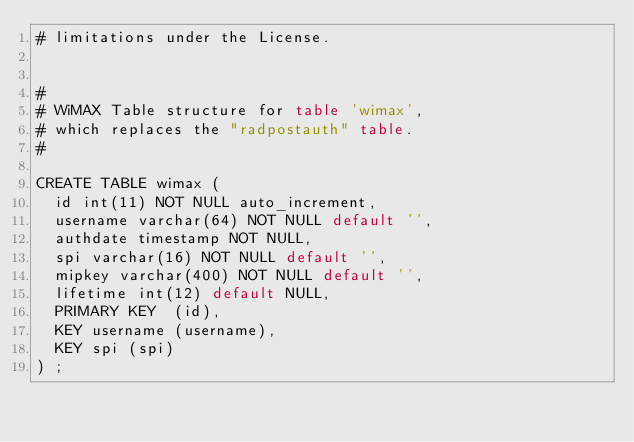Convert code to text. <code><loc_0><loc_0><loc_500><loc_500><_SQL_># limitations under the License.


#
# WiMAX Table structure for table 'wimax',
# which replaces the "radpostauth" table.
#

CREATE TABLE wimax (
  id int(11) NOT NULL auto_increment,
  username varchar(64) NOT NULL default '',
  authdate timestamp NOT NULL,
  spi varchar(16) NOT NULL default '',
  mipkey varchar(400) NOT NULL default '',
  lifetime int(12) default NULL,
  PRIMARY KEY  (id),
  KEY username (username),
  KEY spi (spi)
) ;
</code> 